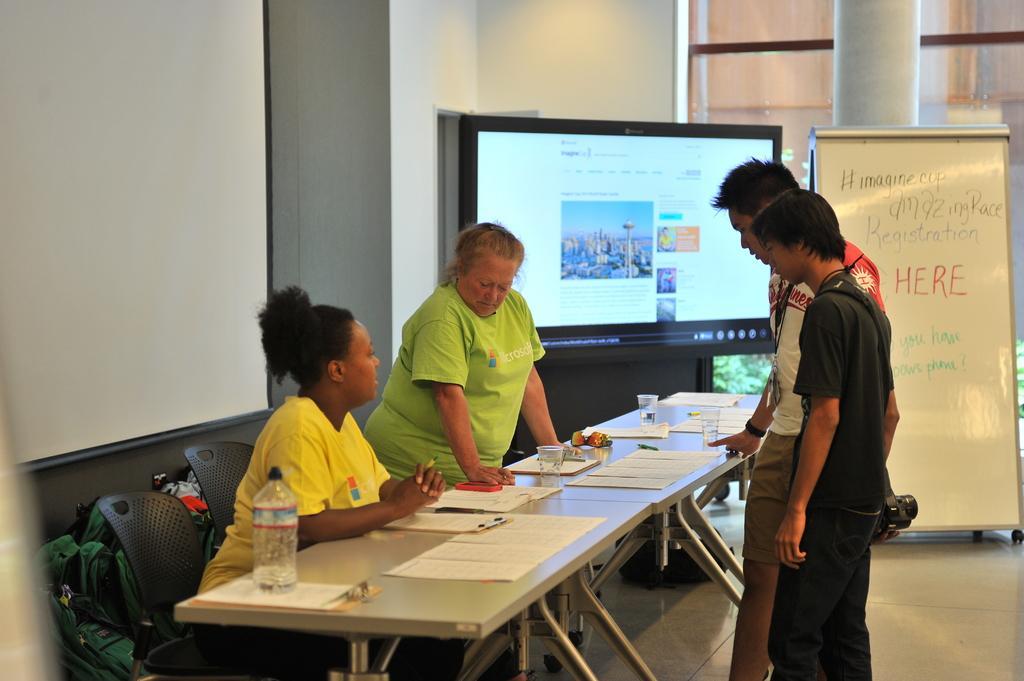In one or two sentences, can you explain what this image depicts? In the picture there are two women and two men standing in front of a table one woman is sitting on the chair on the table there are bottles papers glasses near to the table there is an LED screen near to the LCD screen there is a board with a text on it. 